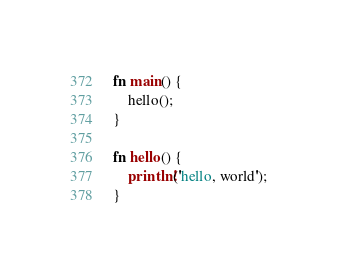<code> <loc_0><loc_0><loc_500><loc_500><_Rust_>
fn main() {
	hello();
}

fn hello() {
	println!('hello, world');
}


</code> 